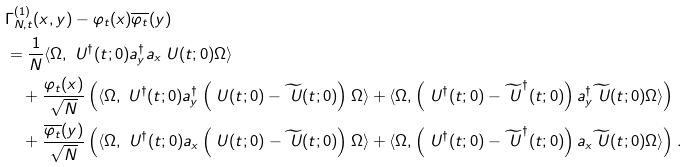<formula> <loc_0><loc_0><loc_500><loc_500>& \Gamma _ { N , t } ^ { ( 1 ) } ( x , y ) - \varphi _ { t } ( x ) \overline { \varphi _ { t } } ( y ) \\ & = \frac { 1 } { N } \langle \Omega , \ U ^ { \dag } ( t ; 0 ) a _ { y } ^ { \dag } a _ { x } \ U ( t ; 0 ) \Omega \rangle \\ & \quad + \frac { \varphi _ { t } ( x ) } { \sqrt { N } } \left ( \langle \Omega , \ U ^ { \dag } ( t ; 0 ) a _ { y } ^ { \dag } \left ( \ U ( t ; 0 ) - \widetilde { \ U } ( t ; 0 ) \right ) \Omega \rangle + \langle \Omega , \left ( \ U ^ { \dag } ( t ; 0 ) - \widetilde { \ U } ^ { \dag } ( t ; 0 ) \right ) a _ { y } ^ { \dag } \widetilde { \ U } ( t ; 0 ) \Omega \rangle \right ) \\ & \quad + \frac { \overline { \varphi _ { t } } ( y ) } { \sqrt { N } } \left ( \langle \Omega , \ U ^ { \dag } ( t ; 0 ) a _ { x } \left ( \ U ( t ; 0 ) - \widetilde { \ U } ( t ; 0 ) \right ) \Omega \rangle + \langle \Omega , \left ( \ U ^ { \dag } ( t ; 0 ) - \widetilde { \ U } ^ { \dag } ( t ; 0 ) \right ) a _ { x } \widetilde { \ U } ( t ; 0 ) \Omega \rangle \right ) .</formula> 